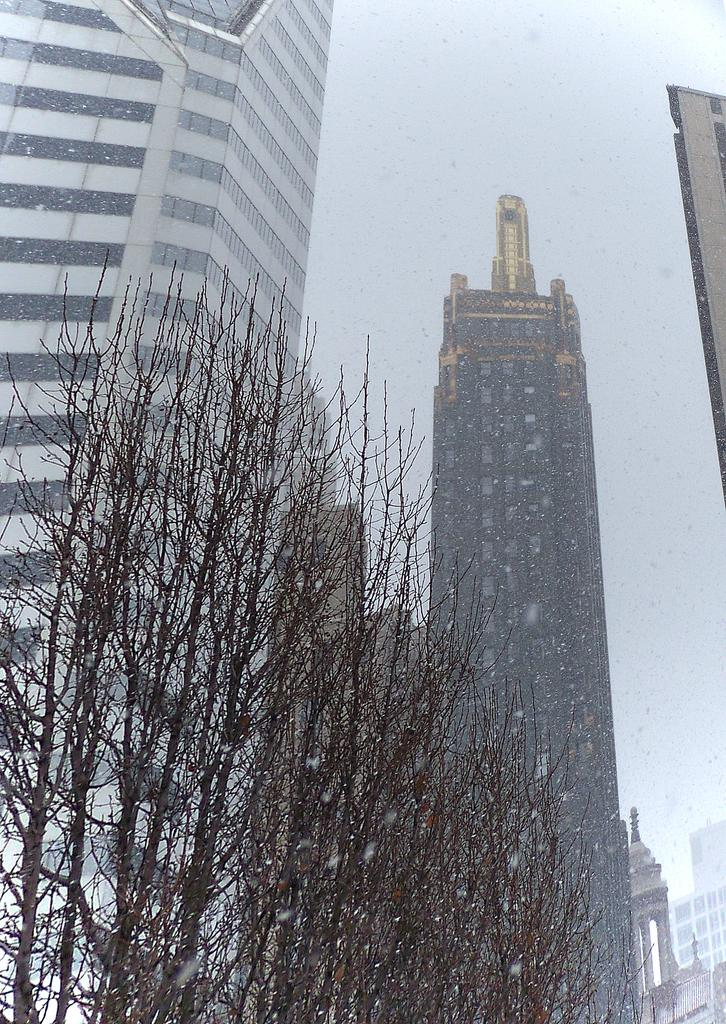What type of natural elements can be seen in the image? There are trees in the image. What type of man-made structures are present in the image? There are buildings in the image. Where are the buildings located in relation to the image? The buildings are in the middle of the image. What is visible at the top of the image? The sky is visible at the top of the image. What type of bell can be heard ringing in the image? There is no bell present in the image, and therefore no sound can be heard. What type of hall is visible in the image? There is no hall present in the image. 